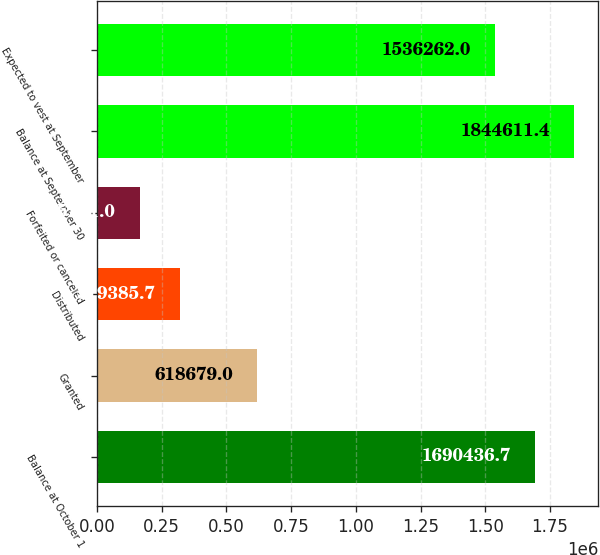<chart> <loc_0><loc_0><loc_500><loc_500><bar_chart><fcel>Balance at October 1<fcel>Granted<fcel>Distributed<fcel>Forfeited or canceled<fcel>Balance at September 30<fcel>Expected to vest at September<nl><fcel>1.69044e+06<fcel>618679<fcel>319386<fcel>165211<fcel>1.84461e+06<fcel>1.53626e+06<nl></chart> 